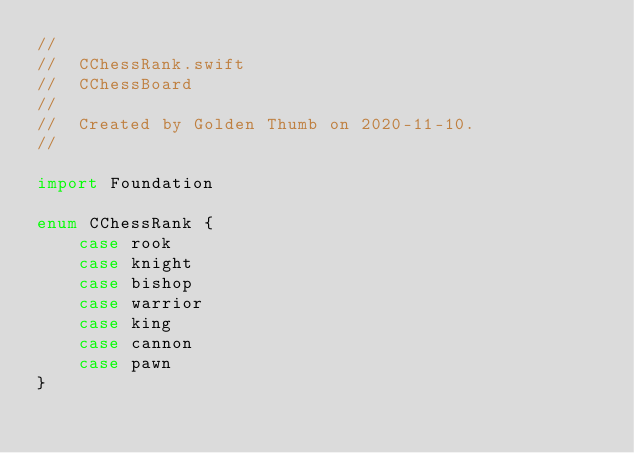<code> <loc_0><loc_0><loc_500><loc_500><_Swift_>//
//  CChessRank.swift
//  CChessBoard
//
//  Created by Golden Thumb on 2020-11-10.
//

import Foundation

enum CChessRank {
    case rook
    case knight
    case bishop
    case warrior
    case king
    case cannon
    case pawn
}
</code> 